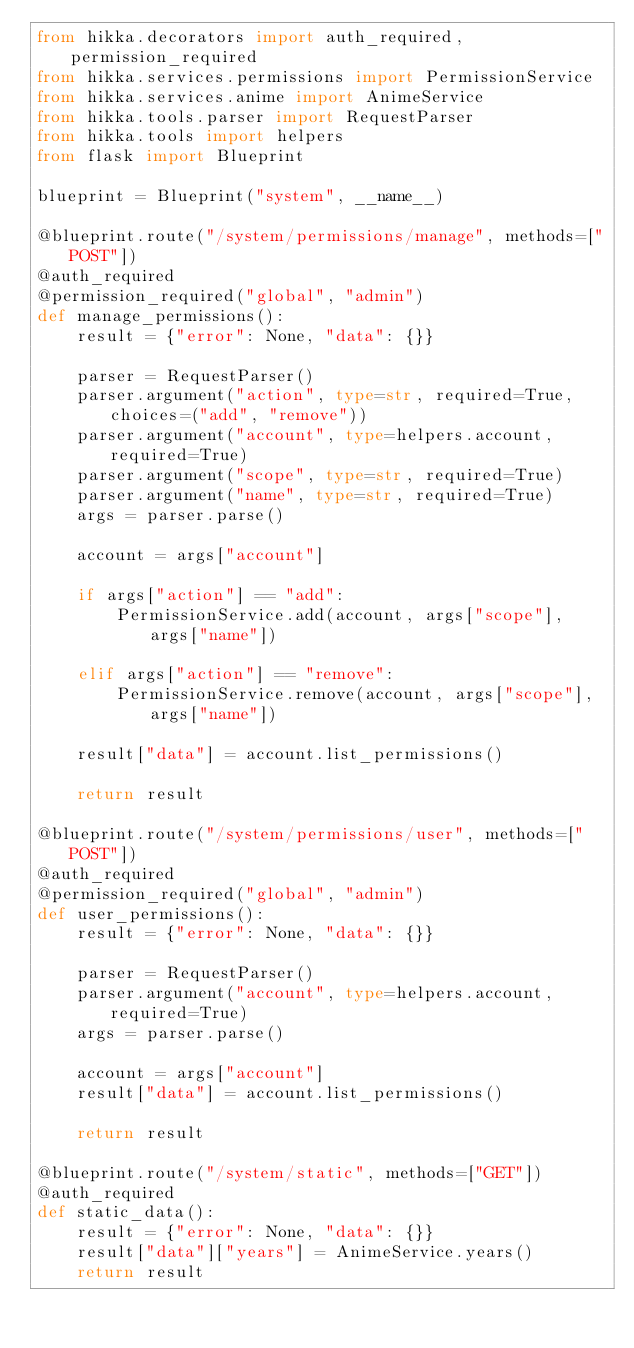Convert code to text. <code><loc_0><loc_0><loc_500><loc_500><_Python_>from hikka.decorators import auth_required, permission_required
from hikka.services.permissions import PermissionService
from hikka.services.anime import AnimeService
from hikka.tools.parser import RequestParser
from hikka.tools import helpers
from flask import Blueprint

blueprint = Blueprint("system", __name__)

@blueprint.route("/system/permissions/manage", methods=["POST"])
@auth_required
@permission_required("global", "admin")
def manage_permissions():
    result = {"error": None, "data": {}}

    parser = RequestParser()
    parser.argument("action", type=str, required=True, choices=("add", "remove"))
    parser.argument("account", type=helpers.account, required=True)
    parser.argument("scope", type=str, required=True)
    parser.argument("name", type=str, required=True)
    args = parser.parse()

    account = args["account"]

    if args["action"] == "add":
        PermissionService.add(account, args["scope"], args["name"])

    elif args["action"] == "remove":
        PermissionService.remove(account, args["scope"], args["name"])

    result["data"] = account.list_permissions()

    return result

@blueprint.route("/system/permissions/user", methods=["POST"])
@auth_required
@permission_required("global", "admin")
def user_permissions():
    result = {"error": None, "data": {}}

    parser = RequestParser()
    parser.argument("account", type=helpers.account, required=True)
    args = parser.parse()

    account = args["account"]
    result["data"] = account.list_permissions()

    return result

@blueprint.route("/system/static", methods=["GET"])
@auth_required
def static_data():
    result = {"error": None, "data": {}}
    result["data"]["years"] = AnimeService.years()
    return result
</code> 